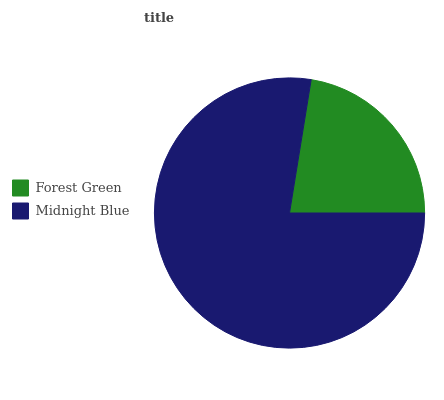Is Forest Green the minimum?
Answer yes or no. Yes. Is Midnight Blue the maximum?
Answer yes or no. Yes. Is Midnight Blue the minimum?
Answer yes or no. No. Is Midnight Blue greater than Forest Green?
Answer yes or no. Yes. Is Forest Green less than Midnight Blue?
Answer yes or no. Yes. Is Forest Green greater than Midnight Blue?
Answer yes or no. No. Is Midnight Blue less than Forest Green?
Answer yes or no. No. Is Midnight Blue the high median?
Answer yes or no. Yes. Is Forest Green the low median?
Answer yes or no. Yes. Is Forest Green the high median?
Answer yes or no. No. Is Midnight Blue the low median?
Answer yes or no. No. 